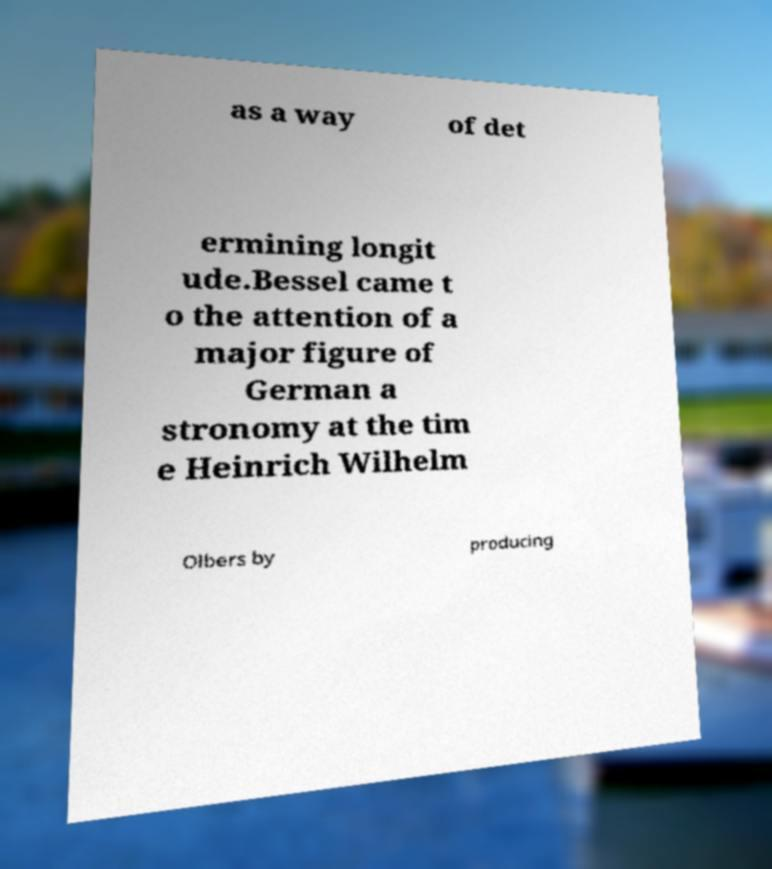For documentation purposes, I need the text within this image transcribed. Could you provide that? as a way of det ermining longit ude.Bessel came t o the attention of a major figure of German a stronomy at the tim e Heinrich Wilhelm Olbers by producing 